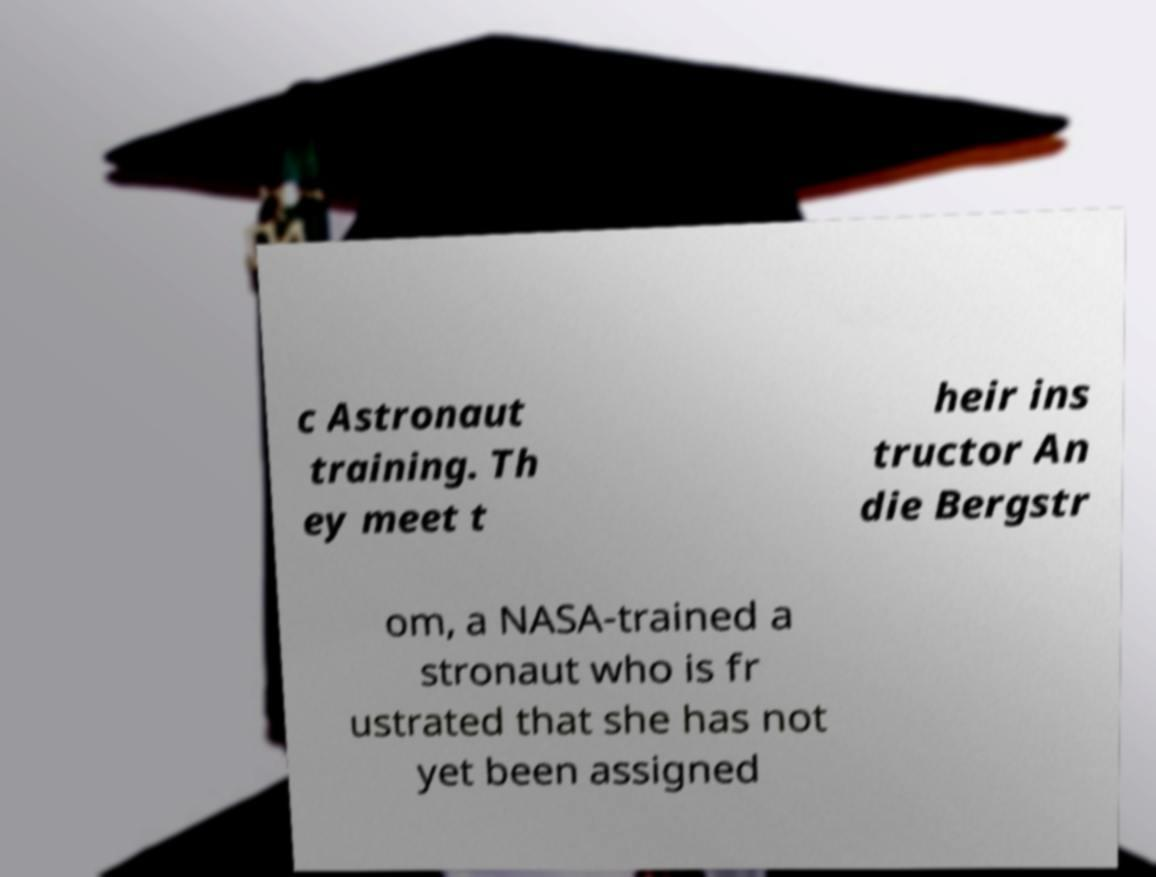There's text embedded in this image that I need extracted. Can you transcribe it verbatim? c Astronaut training. Th ey meet t heir ins tructor An die Bergstr om, a NASA-trained a stronaut who is fr ustrated that she has not yet been assigned 